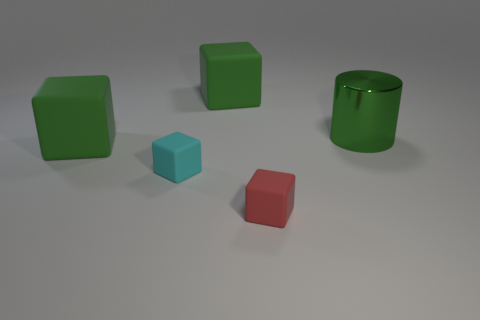The other small block that is the same material as the small cyan block is what color?
Give a very brief answer. Red. There is a large object that is on the left side of the green rubber cube behind the large green metal thing; what is it made of?
Keep it short and to the point. Rubber. How many things are green rubber blocks in front of the shiny cylinder or large rubber blocks that are in front of the green metal object?
Make the answer very short. 1. There is a green cube that is to the left of the small object that is on the left side of the green matte cube to the right of the small cyan thing; what size is it?
Make the answer very short. Large. Are there an equal number of red rubber things in front of the red block and green cubes?
Your answer should be compact. No. Is there anything else that has the same shape as the tiny cyan matte thing?
Your answer should be very brief. Yes. There is a metal object; does it have the same shape as the thing behind the large shiny cylinder?
Your answer should be compact. No. What is the size of the red thing that is the same shape as the cyan matte thing?
Provide a succinct answer. Small. How many other things are the same material as the small red object?
Your answer should be very brief. 3. What is the red block made of?
Make the answer very short. Rubber. 